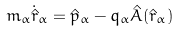Convert formula to latex. <formula><loc_0><loc_0><loc_500><loc_500>m _ { \alpha } \dot { \hat { r } } _ { \alpha } = \hat { p } _ { \alpha } - q _ { \alpha } \hat { A } ( \hat { r } _ { \alpha } )</formula> 